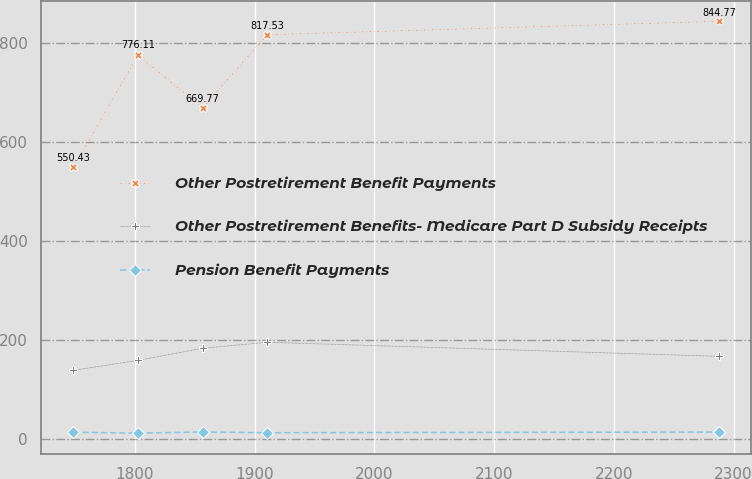Convert chart to OTSL. <chart><loc_0><loc_0><loc_500><loc_500><line_chart><ecel><fcel>Other Postretirement Benefit Payments<fcel>Other Postretirement Benefits- Medicare Part D Subsidy Receipts<fcel>Pension Benefit Payments<nl><fcel>1748.67<fcel>550.43<fcel>139.26<fcel>14.24<nl><fcel>1802.58<fcel>776.11<fcel>159.67<fcel>12.4<nl><fcel>1856.49<fcel>669.77<fcel>183.82<fcel>14.8<nl><fcel>1910.4<fcel>817.53<fcel>196.1<fcel>13.28<nl><fcel>2287.81<fcel>844.77<fcel>167.55<fcel>14.57<nl></chart> 